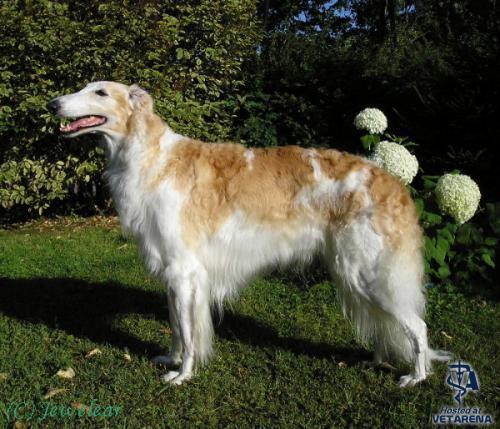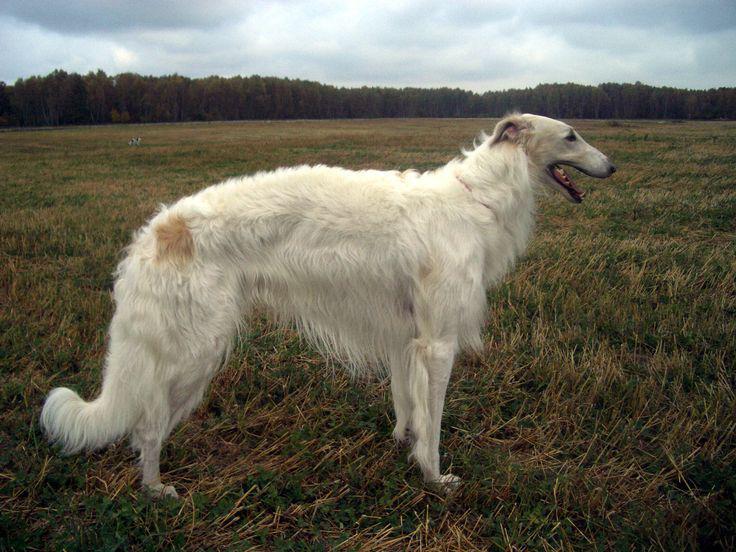The first image is the image on the left, the second image is the image on the right. Considering the images on both sides, is "In at least one image there is a white and light brown dog facing left." valid? Answer yes or no. Yes. 